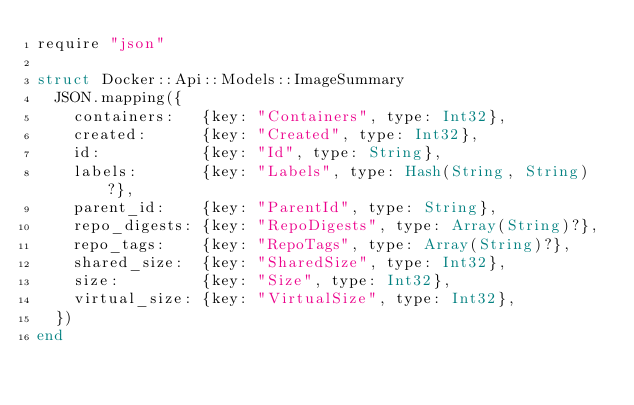Convert code to text. <code><loc_0><loc_0><loc_500><loc_500><_Crystal_>require "json"

struct Docker::Api::Models::ImageSummary
  JSON.mapping({
    containers:   {key: "Containers", type: Int32},
    created:      {key: "Created", type: Int32},
    id:           {key: "Id", type: String},
    labels:       {key: "Labels", type: Hash(String, String)?},
    parent_id:    {key: "ParentId", type: String},
    repo_digests: {key: "RepoDigests", type: Array(String)?},
    repo_tags:    {key: "RepoTags", type: Array(String)?},
    shared_size:  {key: "SharedSize", type: Int32},
    size:         {key: "Size", type: Int32},
    virtual_size: {key: "VirtualSize", type: Int32},
  })
end
</code> 